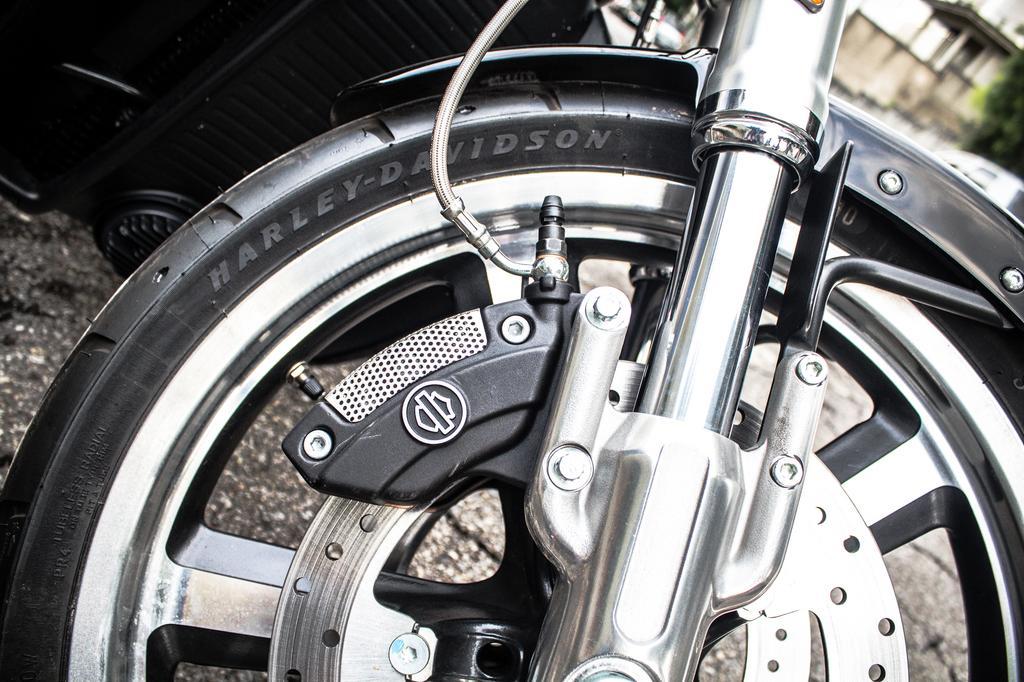Please provide a concise description of this image. In front of the image we can see wheel of a bike with some text on it. Beside the bike there is some object. In the background of the image there is a building and a tree. 